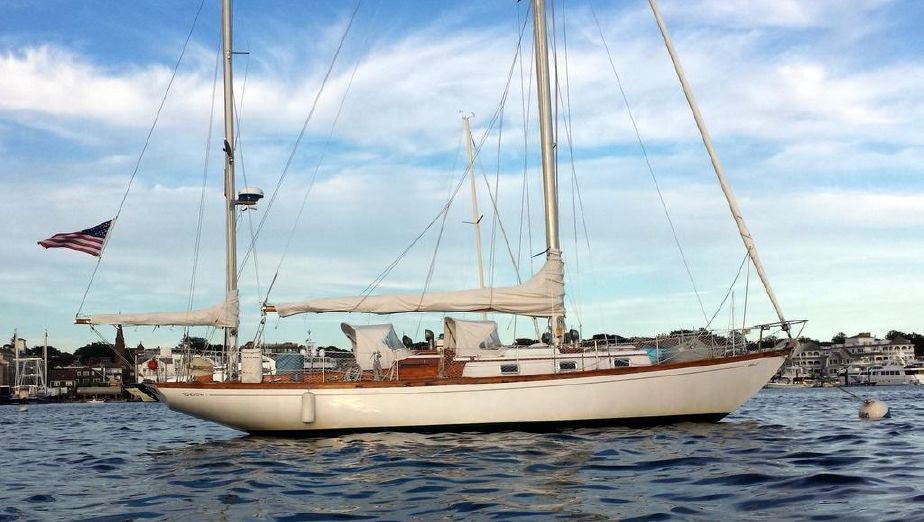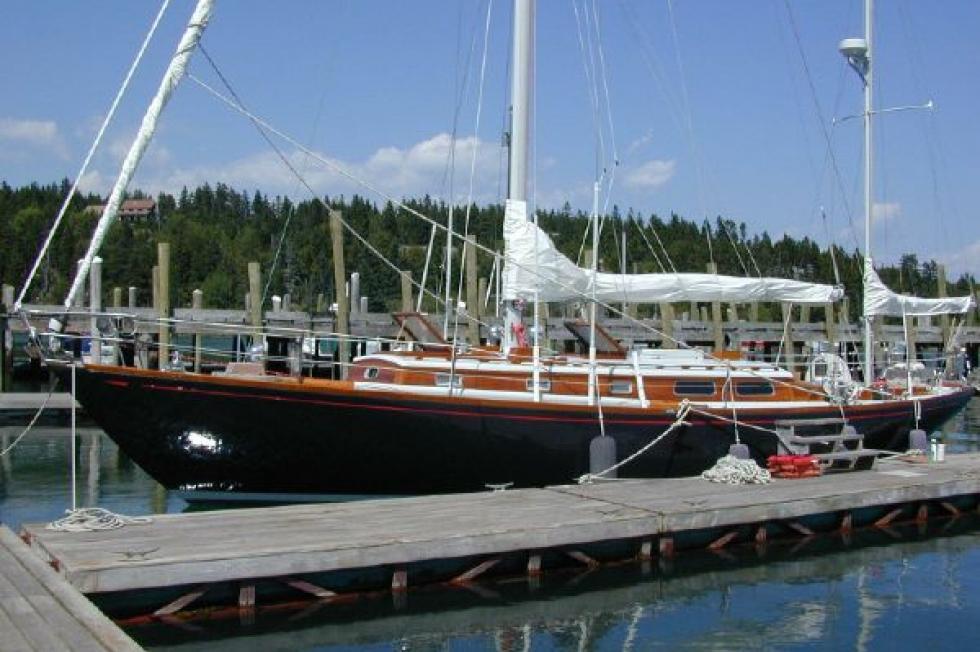The first image is the image on the left, the second image is the image on the right. Given the left and right images, does the statement "The sailboat in the image on the right has a black body." hold true? Answer yes or no. Yes. The first image is the image on the left, the second image is the image on the right. Examine the images to the left and right. Is the description "On the right side of an image, a floating buoy extends from a boat into the water by a rope." accurate? Answer yes or no. Yes. 